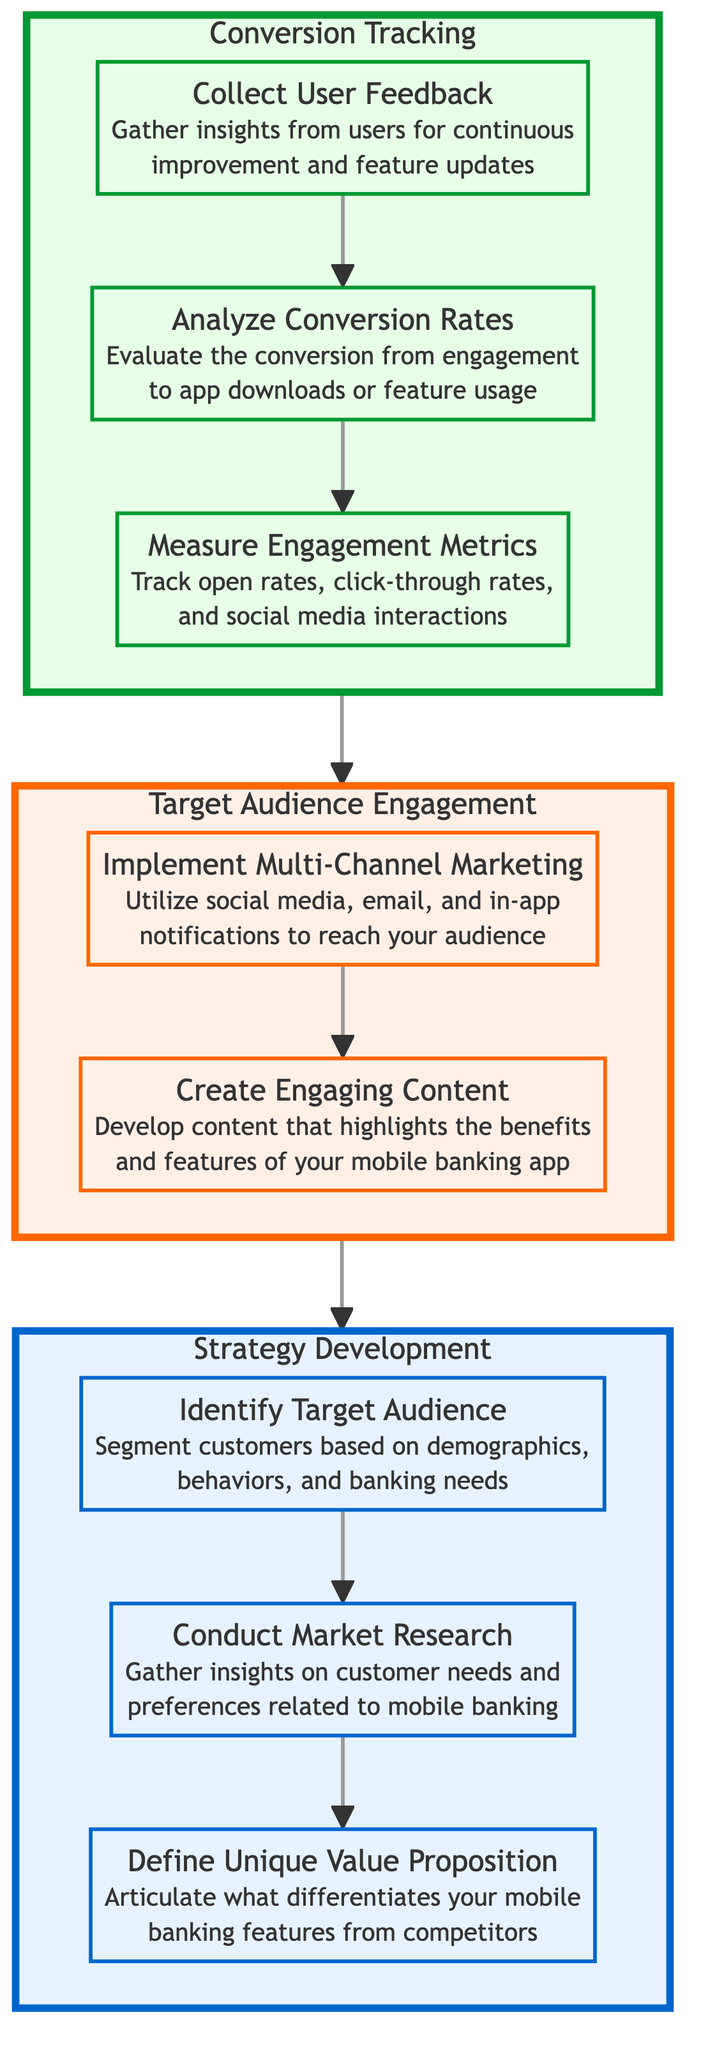What is the first step in the Strategy Development stage? The first step in the Strategy Development stage is defined as "Define Unique Value Proposition." This is indicated in the diagram as the first node listed under the Strategy Development section.
Answer: Define Unique Value Proposition How many nodes are in the Conversion Tracking stage? In the diagram, the Conversion Tracking stage consists of three nodes: "Measure Engagement Metrics," "Analyze Conversion Rates," and "Collect User Feedback." Therefore, there are three nodes in this stage.
Answer: 3 Which node follows "Conduct Market Research"? The node that follows "Conduct Market Research" in the flow is "Identify Target Audience." This relationship is depicted by the directed arrow leading from Conduct Market Research to Identify Target Audience.
Answer: Identify Target Audience What stage is "Create Engaging Content" part of? "Create Engaging Content" is part of the Target Audience Engagement stage, which is clearly labeled in the diagram as the section that includes this specific node.
Answer: Target Audience Engagement Which step involves gathering insights on user feedback? The step that involves gathering insights on user feedback is "Collect User Feedback," which is the last node in the Conversion Tracking stage. This information is provided directly in the node description.
Answer: Collect User Feedback What is the last step in the Target Audience Engagement stage? The last step in the Target Audience Engagement stage is "Create Engaging Content." This is the final node listed under the Engagement section of the diagram.
Answer: Create Engaging Content In what order do the stages flow? The flow order starts with the Strategy Development stage, followed by the Target Audience Engagement stage, and finally leads to the Conversion Tracking stage. This progression is indicated by the arrows connecting these sections in the diagram.
Answer: Strategy Development, Target Audience Engagement, Conversion Tracking What is the relationship between "Implement Multi-Channel Marketing" and "Create Engaging Content"? "Implement Multi-Channel Marketing" leads to "Create Engaging Content." This relationship is shown by the arrow pointing from the former node to the latter node within the Target Audience Engagement stage.
Answer: Implement Multi-Channel Marketing leads to Create Engaging Content 